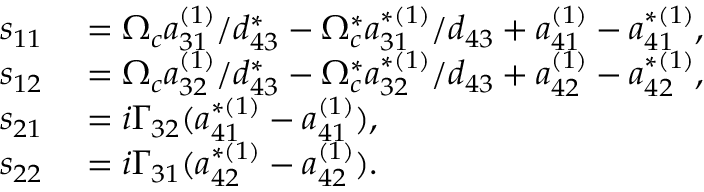<formula> <loc_0><loc_0><loc_500><loc_500>\begin{array} { r l } { s _ { 1 1 } } & = \Omega _ { c } a _ { 3 1 } ^ { ( 1 ) } / d _ { 4 3 } ^ { \ast } - \Omega _ { c } ^ { \ast } a _ { 3 1 } ^ { \ast ( 1 ) } / d _ { 4 3 } + a _ { 4 1 } ^ { ( 1 ) } - a _ { 4 1 } ^ { \ast ( 1 ) } , } \\ { s _ { 1 2 } } & = \Omega _ { c } a _ { 3 2 } ^ { ( 1 ) } / d _ { 4 3 } ^ { \ast } - \Omega _ { c } ^ { \ast } a _ { 3 2 } ^ { \ast ( 1 ) } / d _ { 4 3 } + a _ { 4 2 } ^ { ( 1 ) } - a _ { 4 2 } ^ { \ast ( 1 ) } , } \\ { s _ { 2 1 } } & = i \Gamma _ { 3 2 } ( a _ { 4 1 } ^ { \ast ( 1 ) } - a _ { 4 1 } ^ { ( 1 ) } ) , } \\ { s _ { 2 2 } } & = i \Gamma _ { 3 1 } ( a _ { 4 2 } ^ { \ast ( 1 ) } - a _ { 4 2 } ^ { ( 1 ) } ) . } \end{array}</formula> 